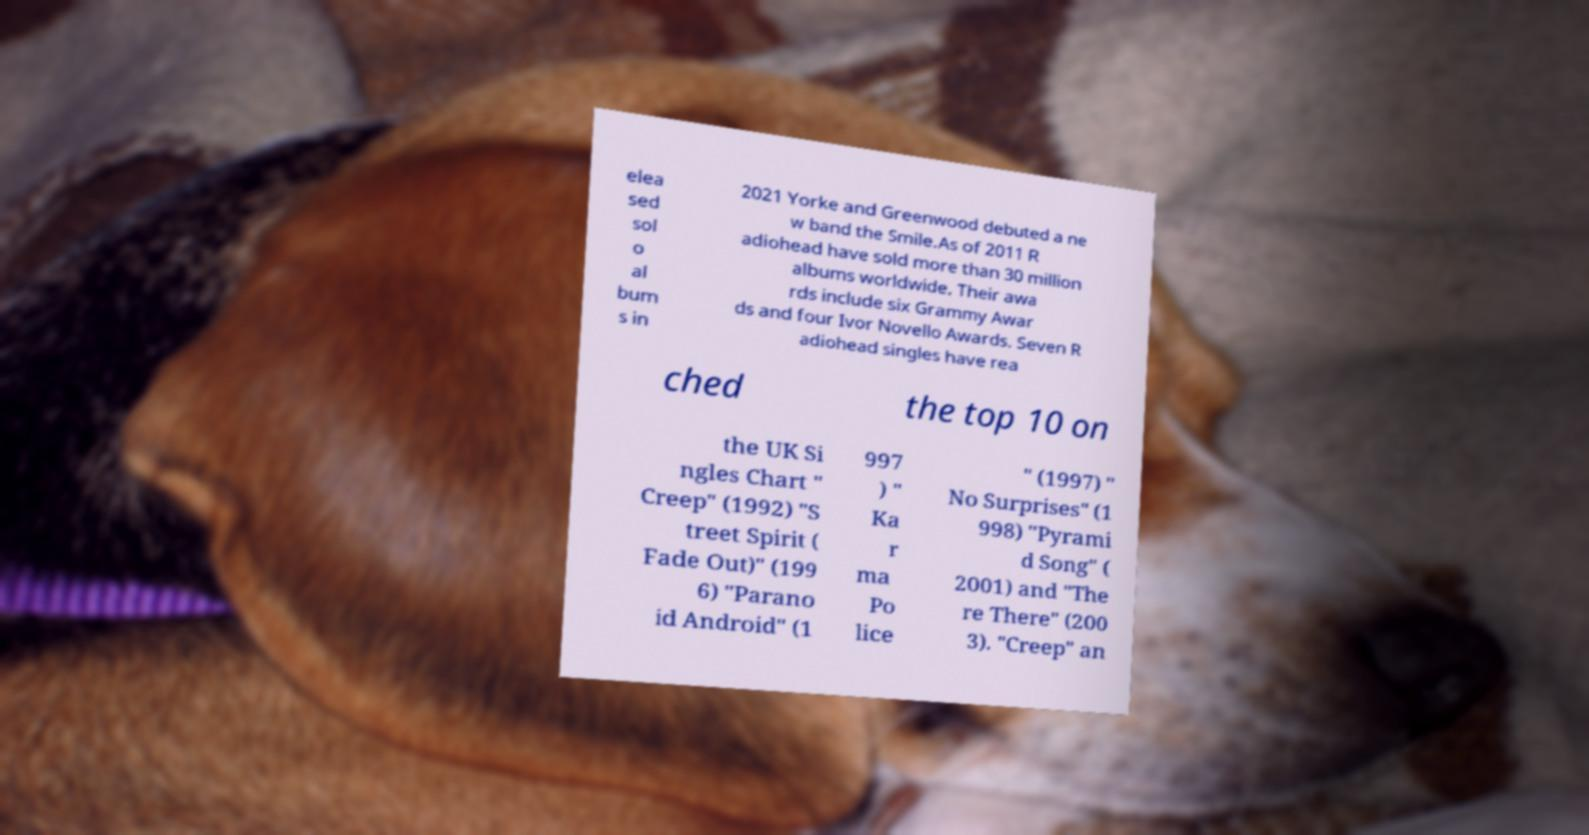Please read and relay the text visible in this image. What does it say? elea sed sol o al bum s in 2021 Yorke and Greenwood debuted a ne w band the Smile.As of 2011 R adiohead have sold more than 30 million albums worldwide. Their awa rds include six Grammy Awar ds and four Ivor Novello Awards. Seven R adiohead singles have rea ched the top 10 on the UK Si ngles Chart " Creep" (1992) "S treet Spirit ( Fade Out)" (199 6) "Parano id Android" (1 997 ) " Ka r ma Po lice " (1997) " No Surprises" (1 998) "Pyrami d Song" ( 2001) and "The re There" (200 3). "Creep" an 